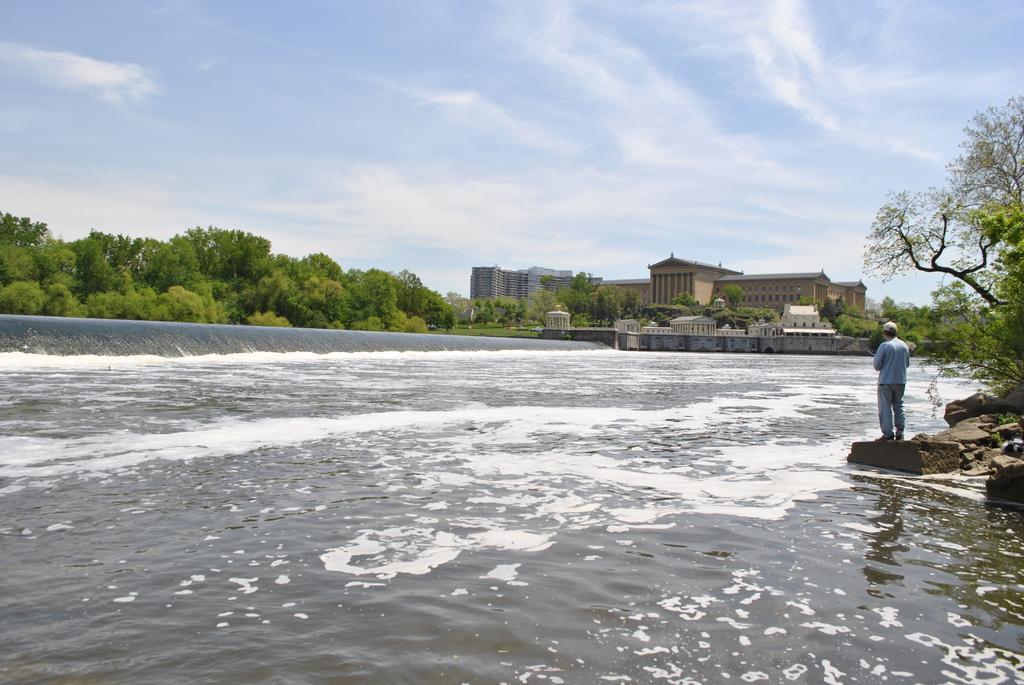Please provide a concise description of this image. In this image we can see a person standing on the stone, water, trees, buildings and sky with clouds. 